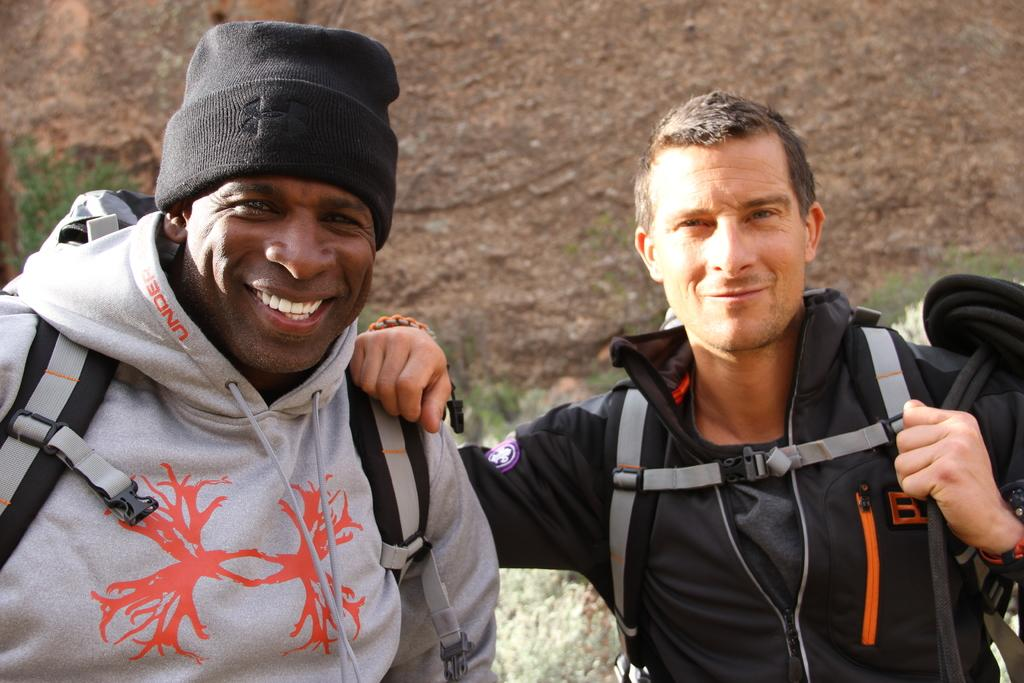How many people are in the image? There are two persons standing in the image. What is the surface on which the persons are standing? The persons are standing on the ground. What can be seen in the background of the image? There is a rock in the background of the image. What type of rings are the persons wearing in the image? There is no mention of rings in the image, so we cannot determine if the persons are wearing any. 